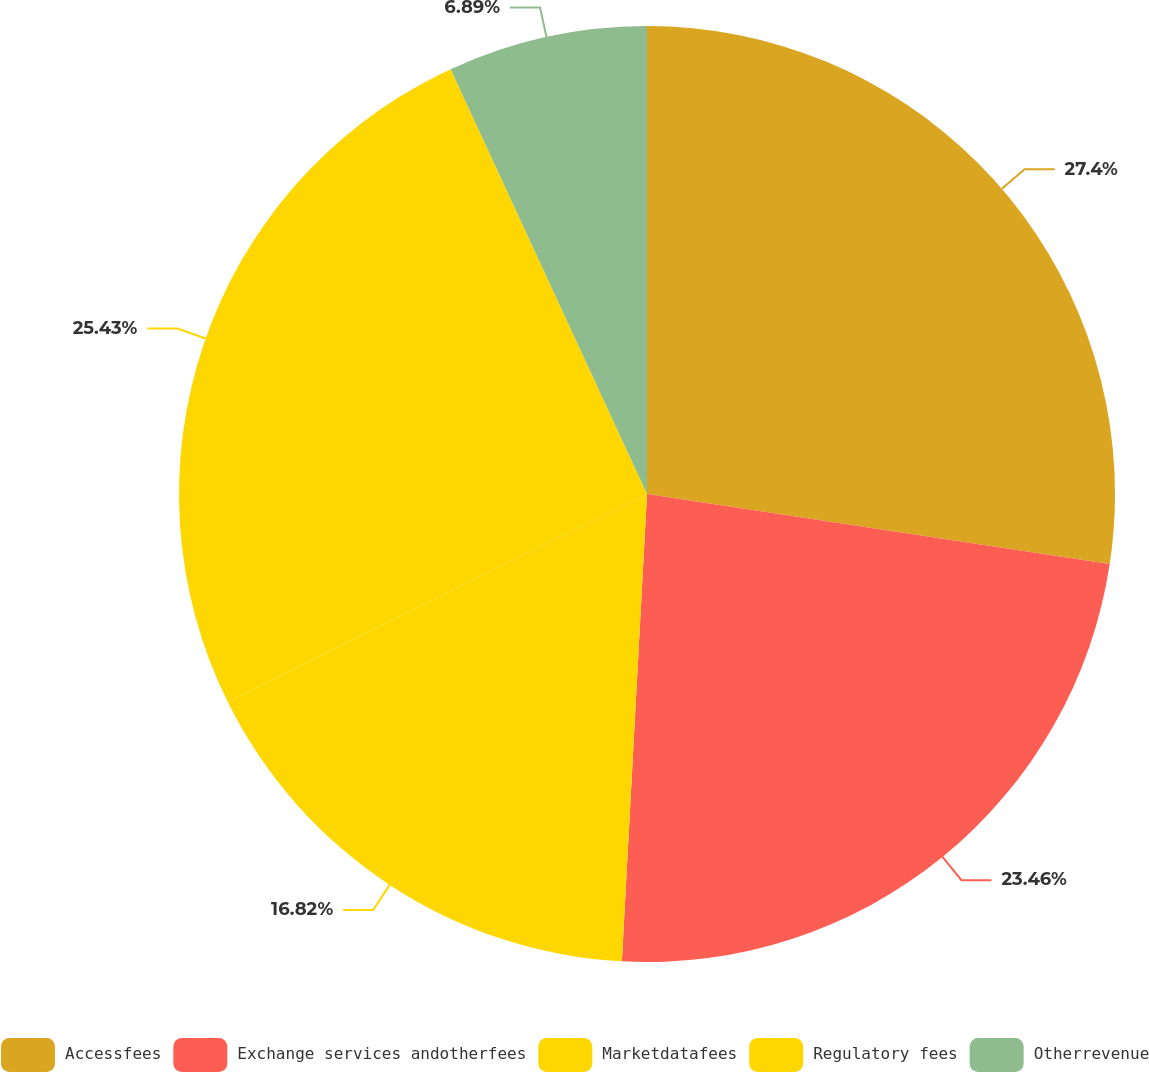Convert chart to OTSL. <chart><loc_0><loc_0><loc_500><loc_500><pie_chart><fcel>Accessfees<fcel>Exchange services andotherfees<fcel>Marketdatafees<fcel>Regulatory fees<fcel>Otherrevenue<nl><fcel>27.39%<fcel>23.46%<fcel>16.82%<fcel>25.43%<fcel>6.89%<nl></chart> 